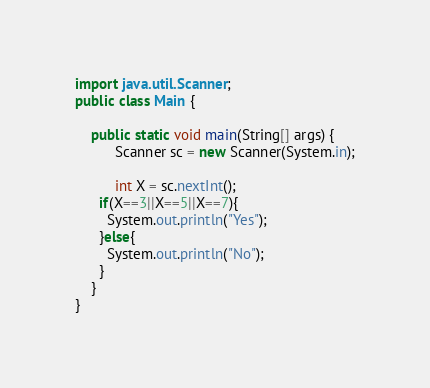Convert code to text. <code><loc_0><loc_0><loc_500><loc_500><_Java_>import java.util.Scanner;
public class Main {
 
	public static void main(String[] args) {
		  Scanner sc = new Scanner(System.in);
	         
          int X = sc.nextInt();
      if(X==3||X==5||X==7){
        System.out.println("Yes");
      }else{
		System.out.println("No");
      }
    }
}</code> 